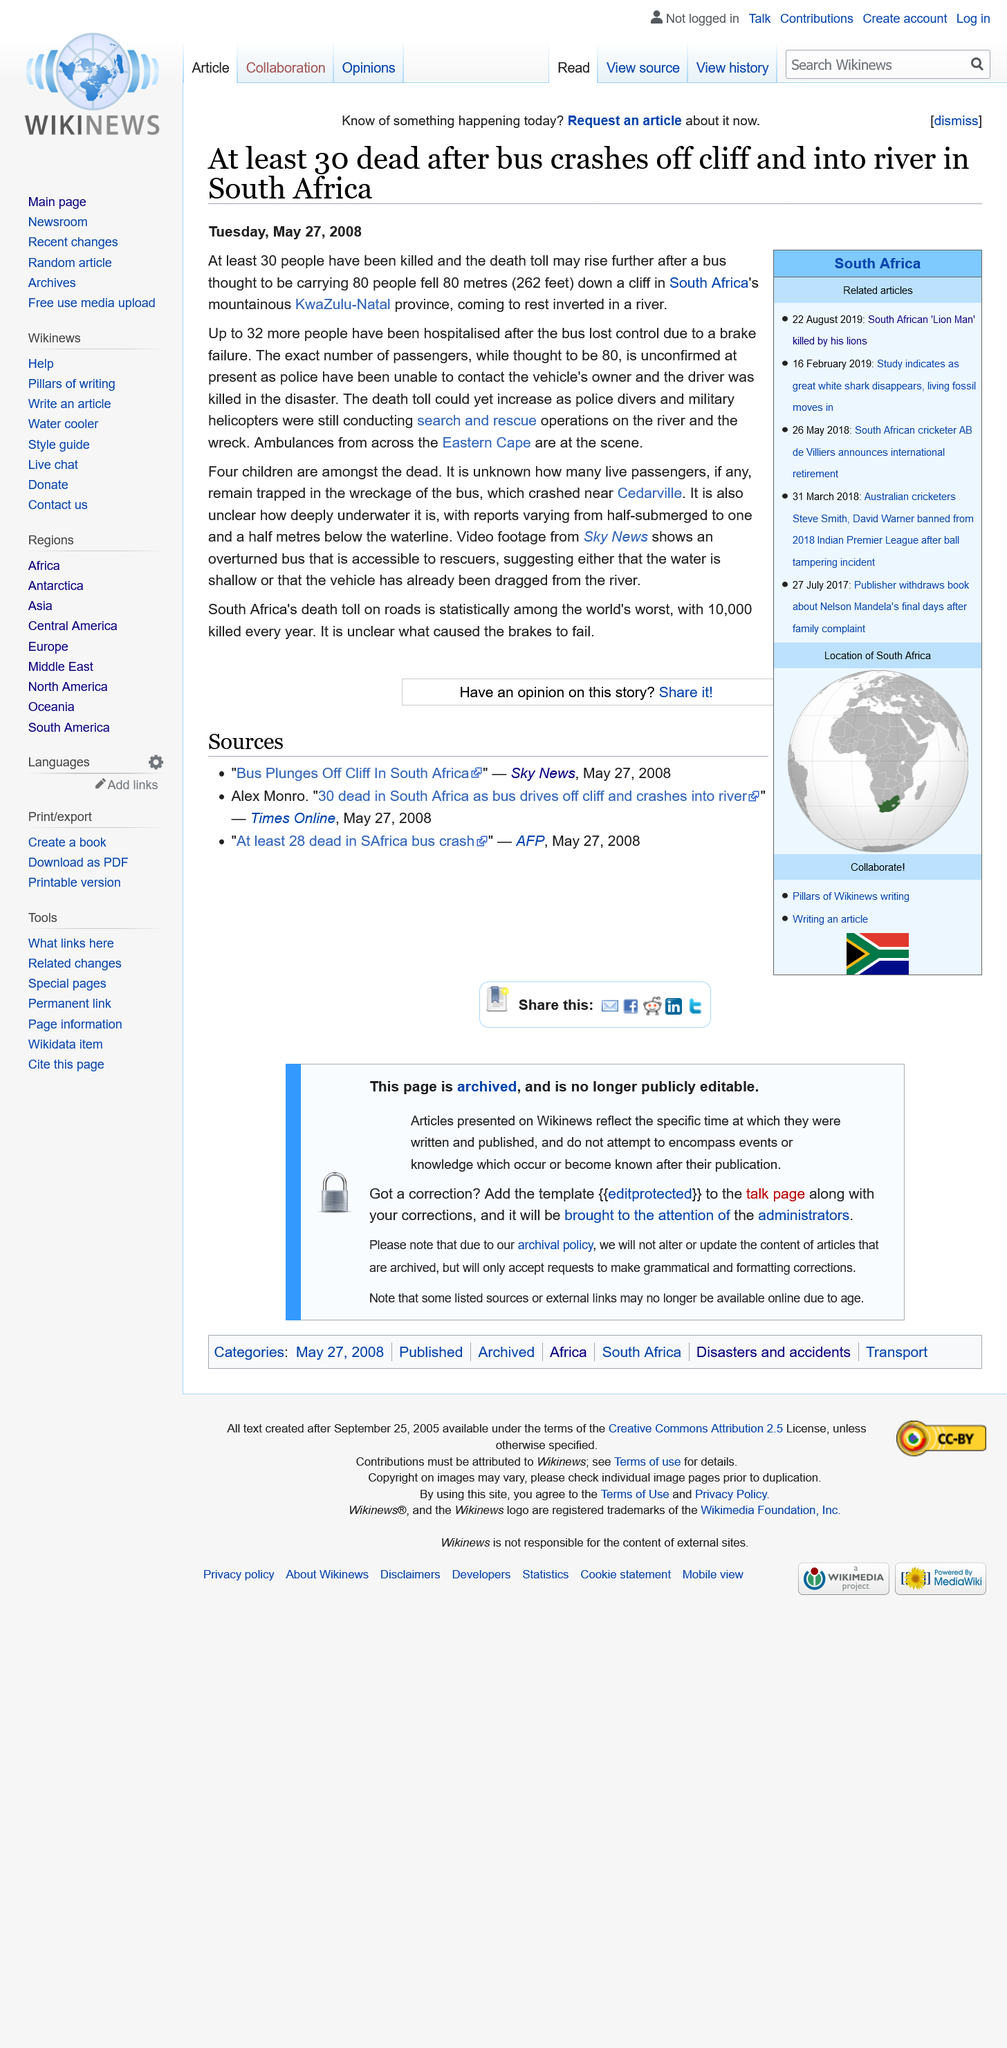Point out several critical features in this image. At least 30 people have been killed. Four children have died. After the bus lost control, a total of 32 people have been hospitalized. 